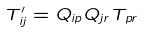Convert formula to latex. <formula><loc_0><loc_0><loc_500><loc_500>T _ { i j } ^ { \prime } = Q _ { i p } Q _ { j r } T _ { p r }</formula> 